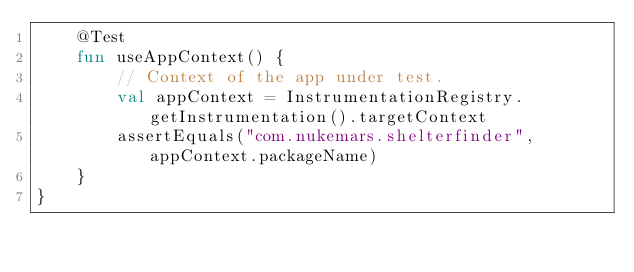Convert code to text. <code><loc_0><loc_0><loc_500><loc_500><_Kotlin_>    @Test
    fun useAppContext() {
        // Context of the app under test.
        val appContext = InstrumentationRegistry.getInstrumentation().targetContext
        assertEquals("com.nukemars.shelterfinder", appContext.packageName)
    }
}</code> 